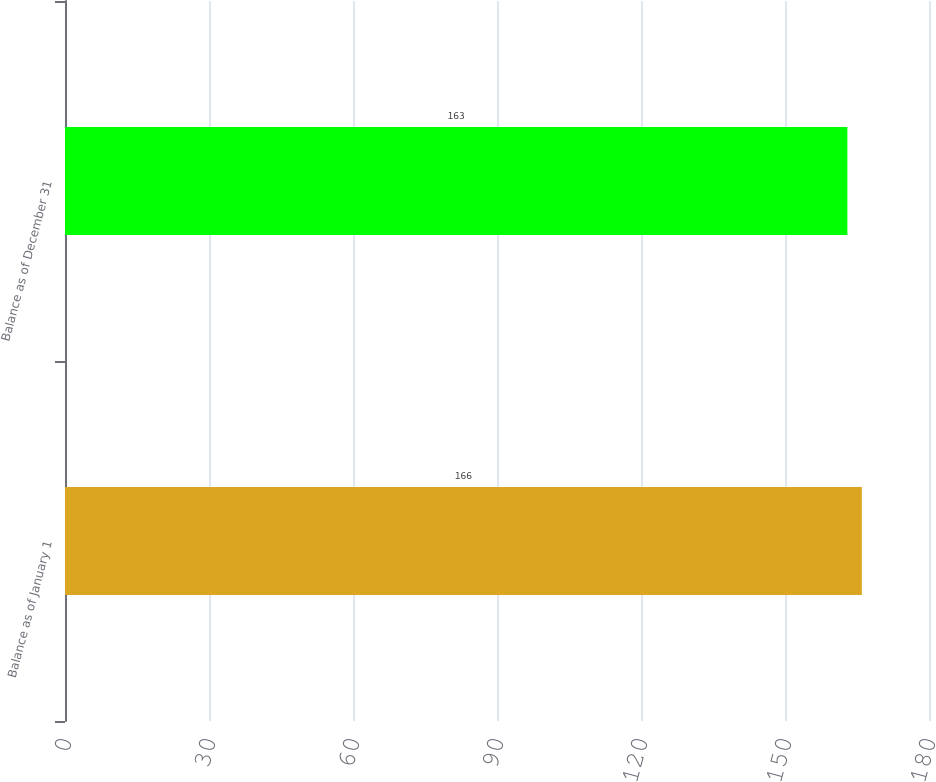Convert chart to OTSL. <chart><loc_0><loc_0><loc_500><loc_500><bar_chart><fcel>Balance as of January 1<fcel>Balance as of December 31<nl><fcel>166<fcel>163<nl></chart> 